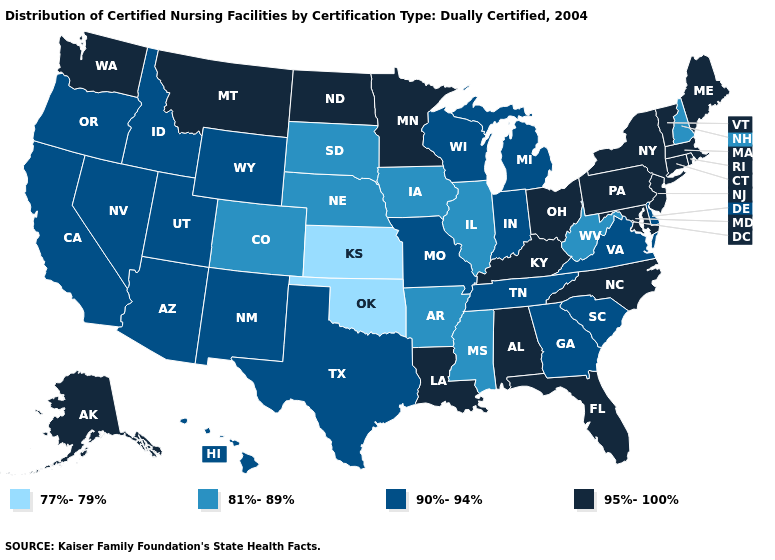Name the states that have a value in the range 81%-89%?
Write a very short answer. Arkansas, Colorado, Illinois, Iowa, Mississippi, Nebraska, New Hampshire, South Dakota, West Virginia. What is the value of New Mexico?
Keep it brief. 90%-94%. What is the value of Florida?
Give a very brief answer. 95%-100%. Does Florida have the same value as South Carolina?
Answer briefly. No. What is the lowest value in states that border New Jersey?
Short answer required. 90%-94%. Which states have the highest value in the USA?
Give a very brief answer. Alabama, Alaska, Connecticut, Florida, Kentucky, Louisiana, Maine, Maryland, Massachusetts, Minnesota, Montana, New Jersey, New York, North Carolina, North Dakota, Ohio, Pennsylvania, Rhode Island, Vermont, Washington. Name the states that have a value in the range 77%-79%?
Quick response, please. Kansas, Oklahoma. What is the highest value in the USA?
Give a very brief answer. 95%-100%. Name the states that have a value in the range 81%-89%?
Be succinct. Arkansas, Colorado, Illinois, Iowa, Mississippi, Nebraska, New Hampshire, South Dakota, West Virginia. What is the highest value in states that border North Dakota?
Give a very brief answer. 95%-100%. What is the lowest value in the USA?
Short answer required. 77%-79%. Does Nevada have a lower value than Pennsylvania?
Write a very short answer. Yes. What is the value of Maryland?
Be succinct. 95%-100%. Name the states that have a value in the range 77%-79%?
Quick response, please. Kansas, Oklahoma. Does the map have missing data?
Keep it brief. No. 